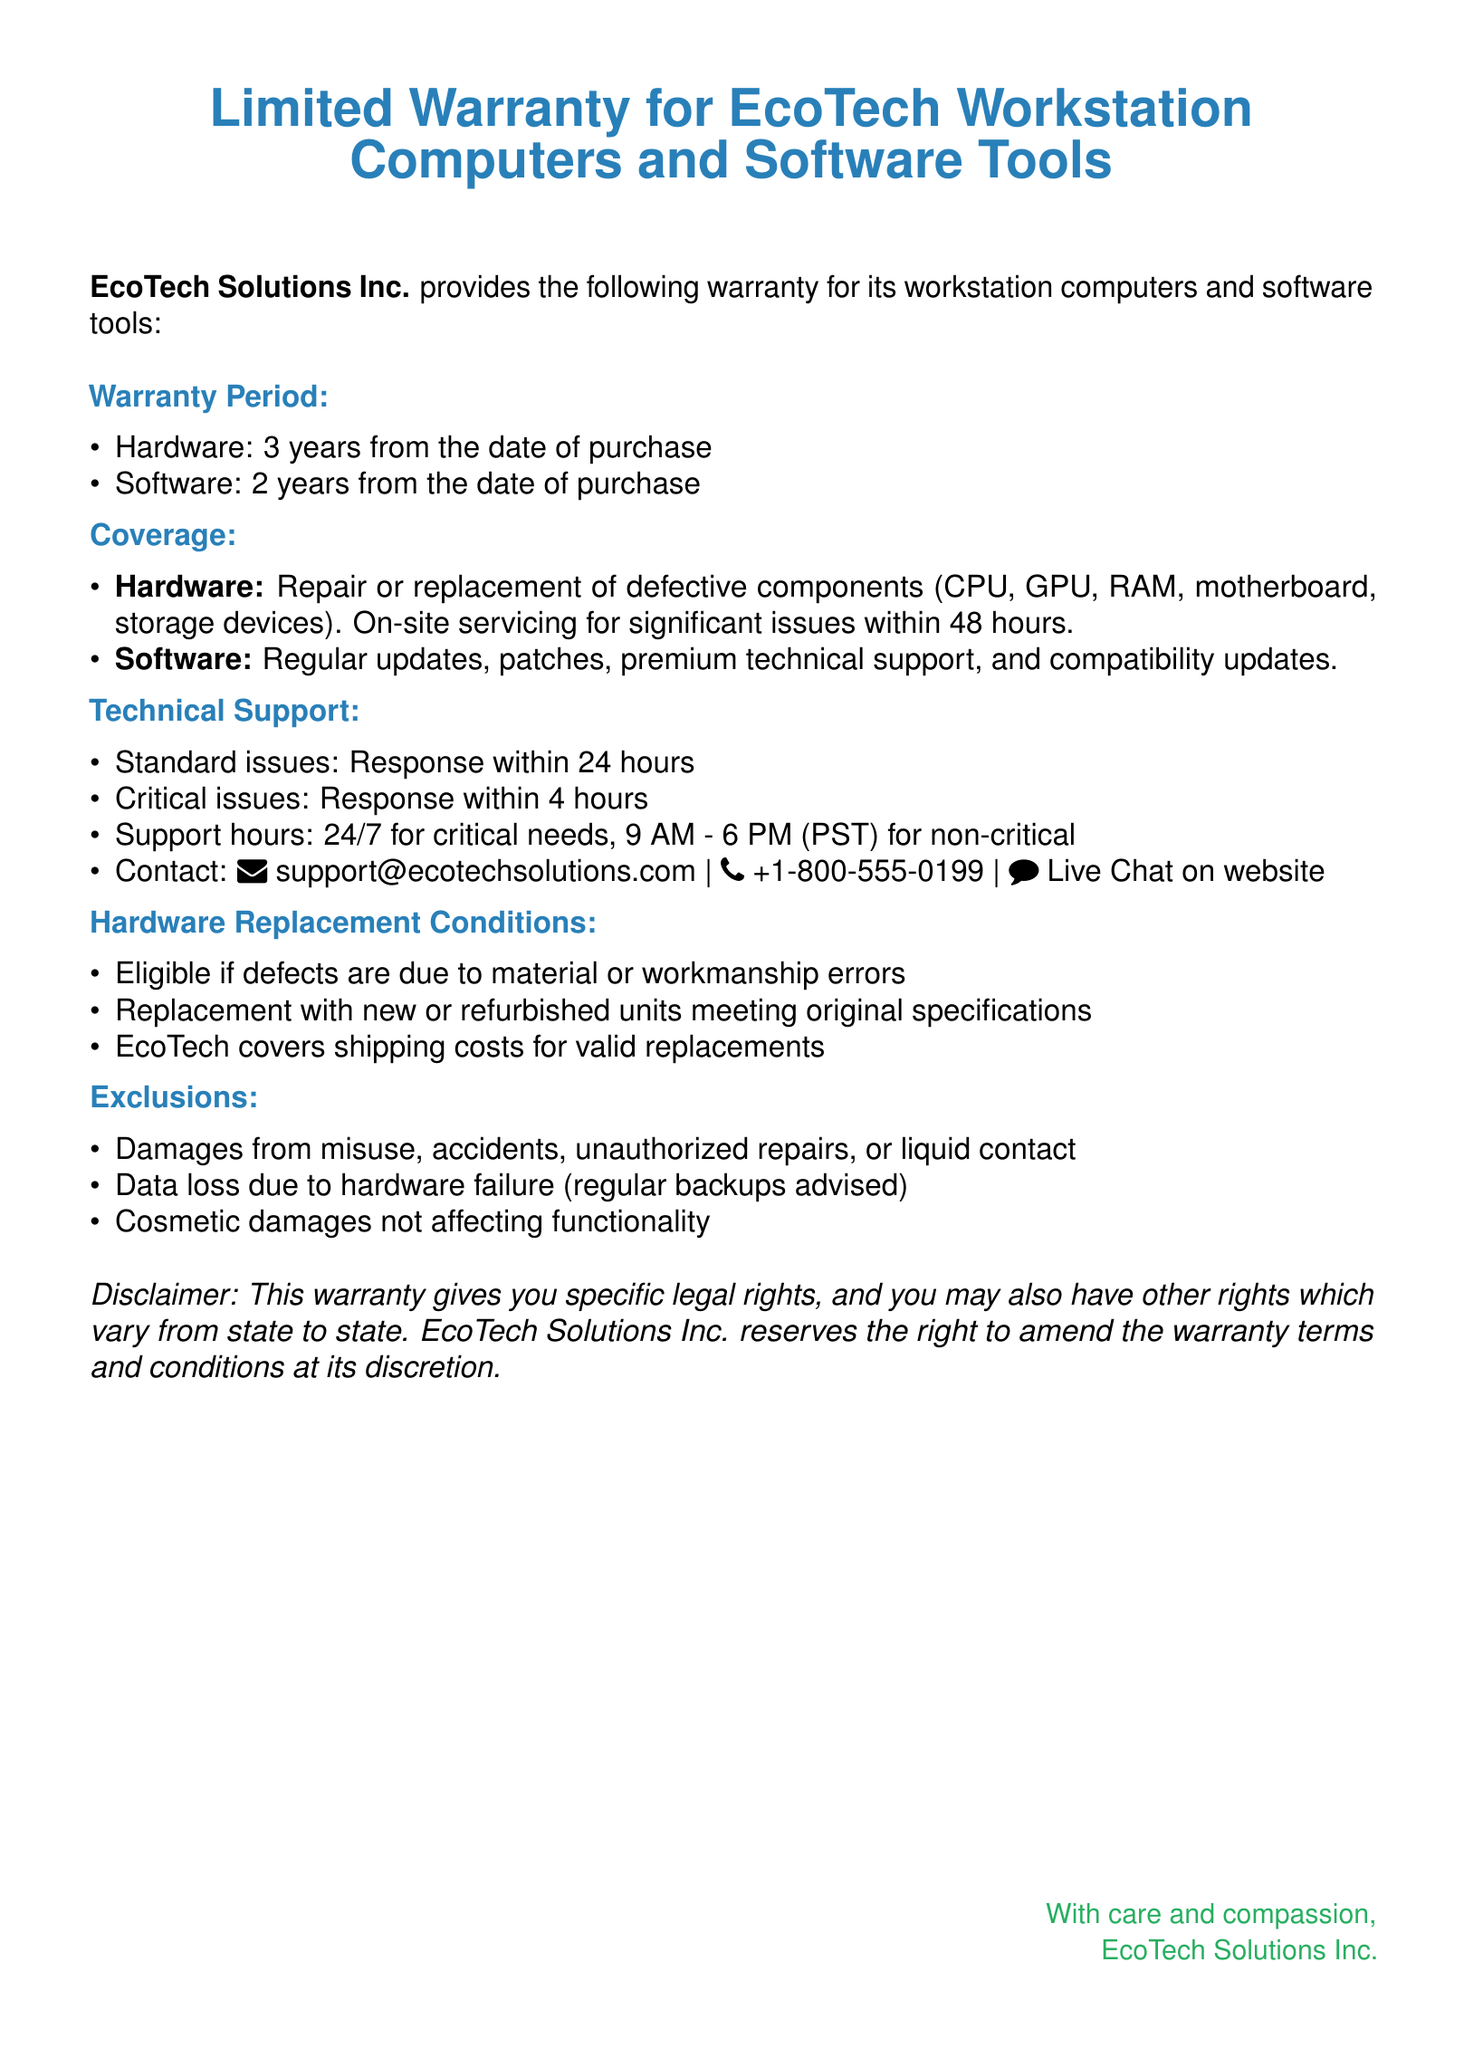What is the warranty period for hardware? The warranty period for hardware is stated as 3 years from the date of purchase.
Answer: 3 years What type of support is available for critical issues? The document specifies that support for critical issues is available 24/7.
Answer: 24/7 What is the response time for standard issues? The response time for standard issues is detailed in the document as within 24 hours.
Answer: 24 hours What coverage does the warranty provide for hardware? The warranty provides repair or replacement for defective components and on-site servicing for significant issues within 48 hours.
Answer: Repair or replacement of defective components Under what conditions are hardware replacements eligible? Hardware replacements are eligible if defects are due to material or workmanship errors.
Answer: Material or workmanship errors What is the shipping cost policy for valid replacements? The warranty states that EcoTech covers shipping costs for valid replacements.
Answer: EcoTech covers shipping costs What is excluded from the warranty coverage? The exclusions include damages from misuse, accidents, unauthorized repairs, or liquid contact.
Answer: Misuse, accidents, unauthorized repairs, or liquid contact What is the contact email for technical support? The contact email for technical support is provided in the document as support@ecotechsolutions.com.
Answer: support@ecotechsolutions.com What are the software coverage aspects? The warranty mentions regular updates, patches, premium technical support, and compatibility updates for software.
Answer: Regular updates, patches, premium technical support, and compatibility updates 